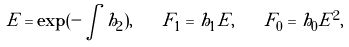Convert formula to latex. <formula><loc_0><loc_0><loc_500><loc_500>E = \exp ( - \int h _ { 2 } ) , \quad F _ { 1 } = h _ { 1 } E , \quad F _ { 0 } = h _ { 0 } E ^ { 2 } ,</formula> 